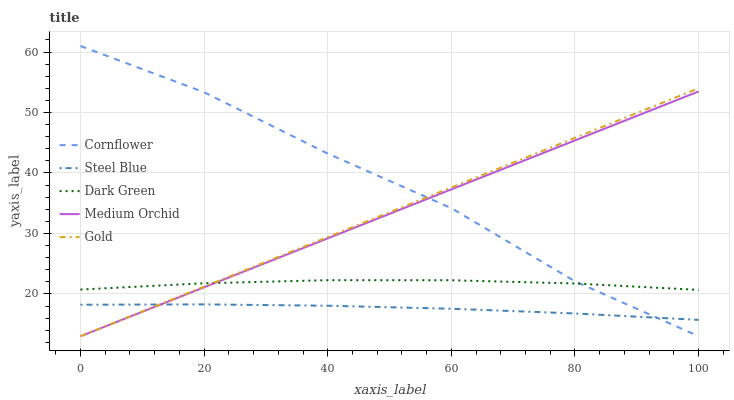Does Steel Blue have the minimum area under the curve?
Answer yes or no. Yes. Does Cornflower have the maximum area under the curve?
Answer yes or no. Yes. Does Medium Orchid have the minimum area under the curve?
Answer yes or no. No. Does Medium Orchid have the maximum area under the curve?
Answer yes or no. No. Is Gold the smoothest?
Answer yes or no. Yes. Is Cornflower the roughest?
Answer yes or no. Yes. Is Medium Orchid the smoothest?
Answer yes or no. No. Is Medium Orchid the roughest?
Answer yes or no. No. Does Cornflower have the lowest value?
Answer yes or no. Yes. Does Steel Blue have the lowest value?
Answer yes or no. No. Does Cornflower have the highest value?
Answer yes or no. Yes. Does Medium Orchid have the highest value?
Answer yes or no. No. Is Steel Blue less than Dark Green?
Answer yes or no. Yes. Is Dark Green greater than Steel Blue?
Answer yes or no. Yes. Does Medium Orchid intersect Gold?
Answer yes or no. Yes. Is Medium Orchid less than Gold?
Answer yes or no. No. Is Medium Orchid greater than Gold?
Answer yes or no. No. Does Steel Blue intersect Dark Green?
Answer yes or no. No. 